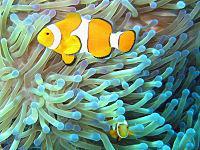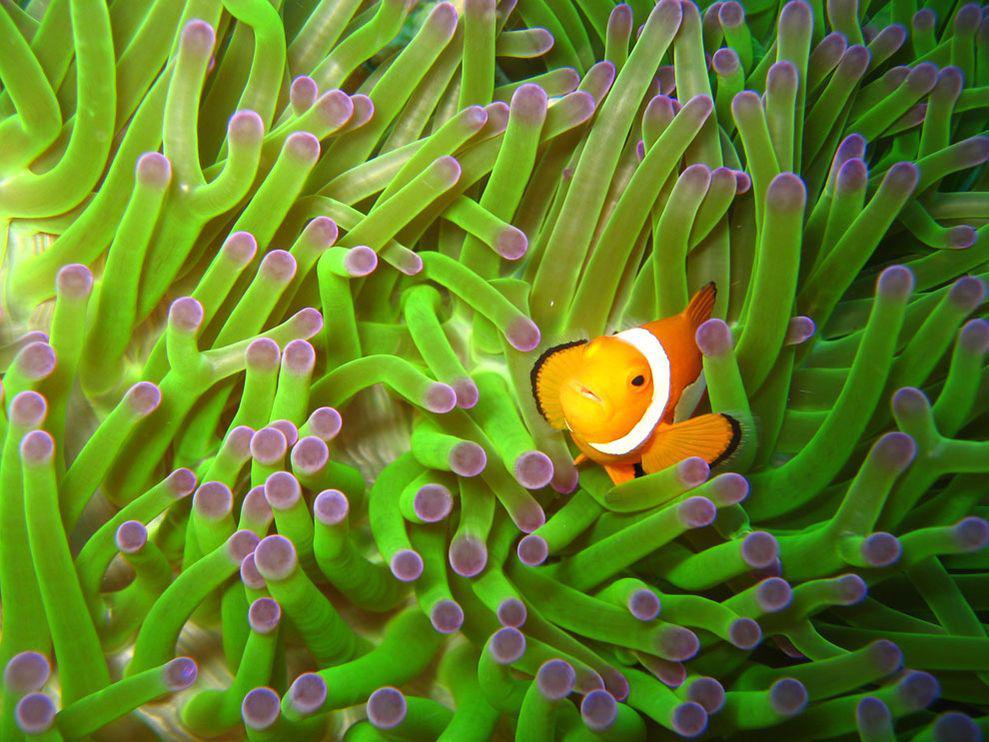The first image is the image on the left, the second image is the image on the right. Given the left and right images, does the statement "There are three clownfish next to a sea anemone in the right image" hold true? Answer yes or no. No. The first image is the image on the left, the second image is the image on the right. Analyze the images presented: Is the assertion "The left image features an anemone with a wide violet-colored stalk, and the right image shows multiple leftward-turned clownfish swimming among anemone tendrils." valid? Answer yes or no. No. 